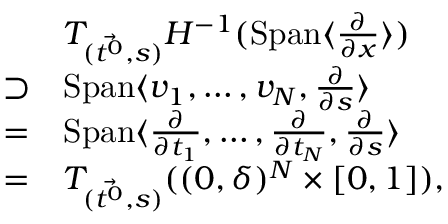Convert formula to latex. <formula><loc_0><loc_0><loc_500><loc_500>\begin{array} { r l } & { T _ { ( \ V e c { t ^ { 0 } } , s ) } H ^ { - 1 } ( S p a n \langle \frac { \partial } { \partial x } \rangle ) } \\ { \supset } & { S p a n \langle v _ { 1 } , \dots , v _ { N } , \frac { \partial } \partial s } \rangle } \\ { = } & { S p a n \langle \frac { \partial } \partial t _ { 1 } } , \dots , \frac { \partial } \partial t _ { N } } , \frac { \partial } \partial s } \rangle } \\ { = } & { T _ { ( \ V e c { t ^ { 0 } } , s ) } ( ( 0 , \delta ) ^ { N } \times [ 0 , 1 ] ) , } \end{array}</formula> 